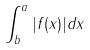<formula> <loc_0><loc_0><loc_500><loc_500>\int _ { b } ^ { a } | f ( x ) | d x</formula> 